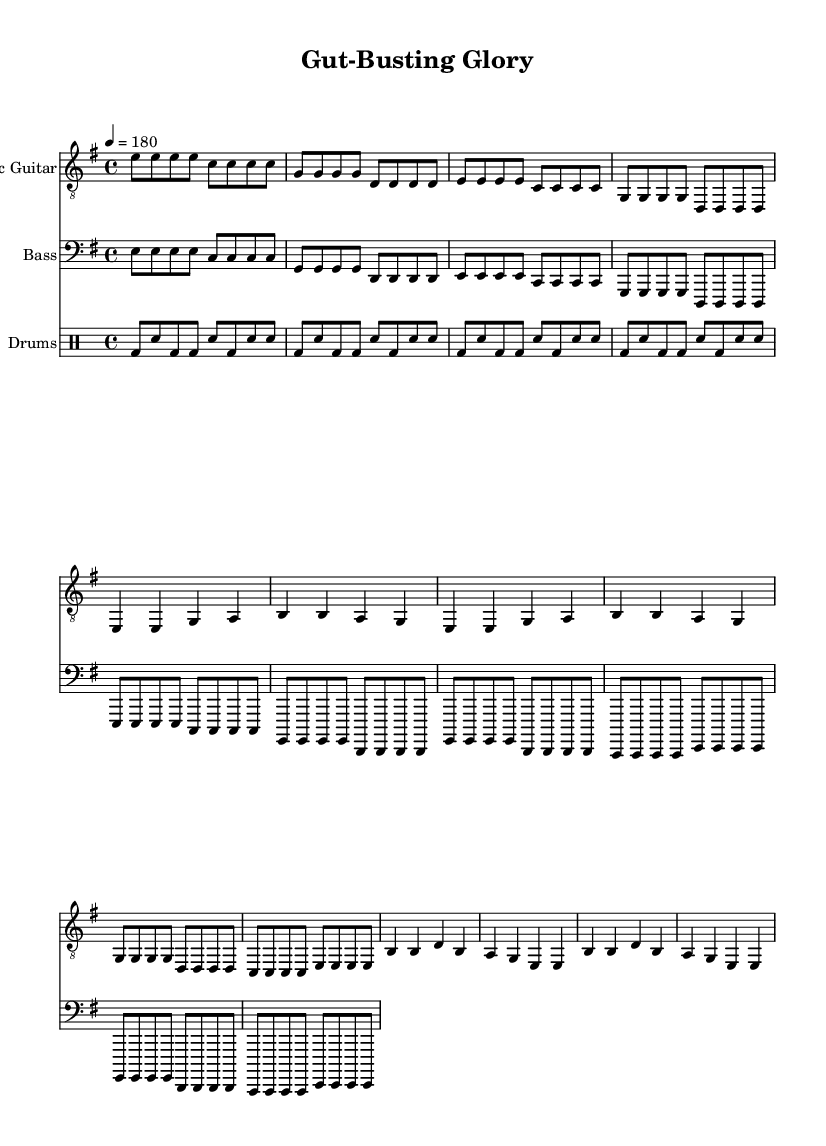What is the key signature of this music? The key signature is E minor, indicated by the presence of one sharp (F#) in the key signature section at the beginning of the music.
Answer: E minor What is the time signature of this piece? The time signature is found at the beginning of the score. In this case, it is shown as 4/4, which means there are four beats in each measure, and the quarter note gets one beat.
Answer: 4/4 What is the tempo marking for this music? The tempo marking is also found at the start of the score, indicated as 4 = 180. This means the music should be played at a speed of 180 beats per minute.
Answer: 180 What type of drum pattern is used throughout the piece? The drumming part uses a basic punk beat, characterized by consistent bass and snare hits. This can be identified by analyzing the recurring pattern in the drum notation.
Answer: Basic punk beat How many measures are there in the verse section? By counting the measures in the verse section of the music, we see that it has a total of 4 measures, as noted by the repeated sections and structure in the music.
Answer: 4 What is the lyrical theme of this song? The lyrics focus on competitive eating, as emphasized by phrases like "Plates piled high" and "Gut-busting glory", which directly relate to challenges faced in food consumption, typical in the hardcore punk themes.
Answer: Competitive eating 